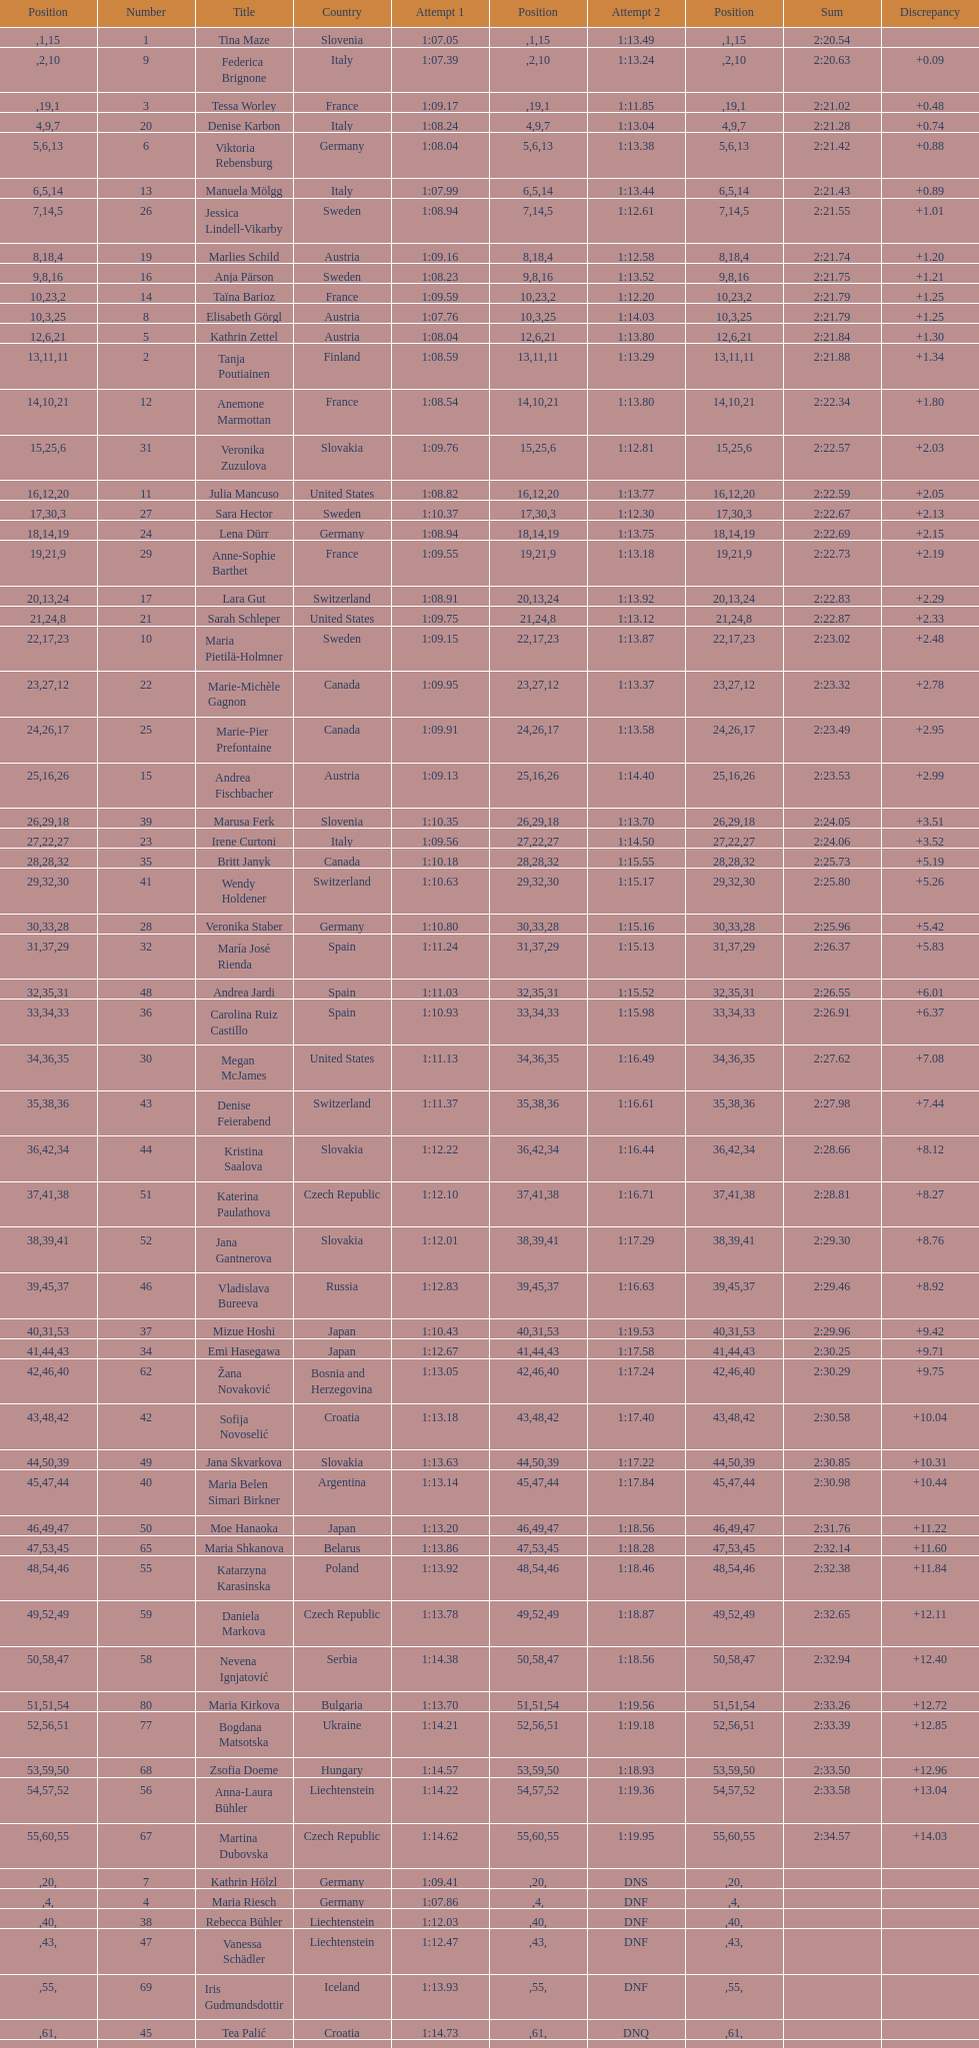How long did it take tina maze to finish the race? 2:20.54. 